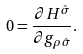Convert formula to latex. <formula><loc_0><loc_0><loc_500><loc_500>0 = \frac { \partial H ^ { \hat { \sigma } } } { \partial g _ { \rho \hat { \sigma } } } .</formula> 